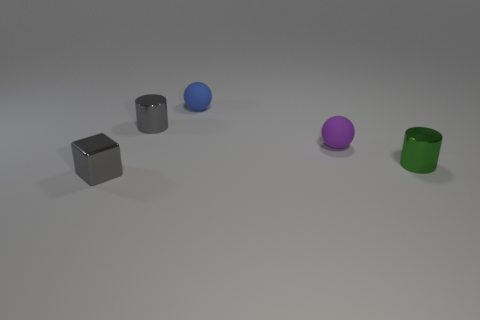Add 4 gray cubes. How many objects exist? 9 Subtract all purple balls. How many balls are left? 1 Subtract all spheres. How many objects are left? 3 Subtract all red cylinders. Subtract all gray spheres. How many cylinders are left? 2 Subtract all brown cubes. How many blue spheres are left? 1 Subtract all small green objects. Subtract all small purple spheres. How many objects are left? 3 Add 3 blue things. How many blue things are left? 4 Add 3 tiny cyan rubber spheres. How many tiny cyan rubber spheres exist? 3 Subtract 0 green balls. How many objects are left? 5 Subtract 1 blocks. How many blocks are left? 0 